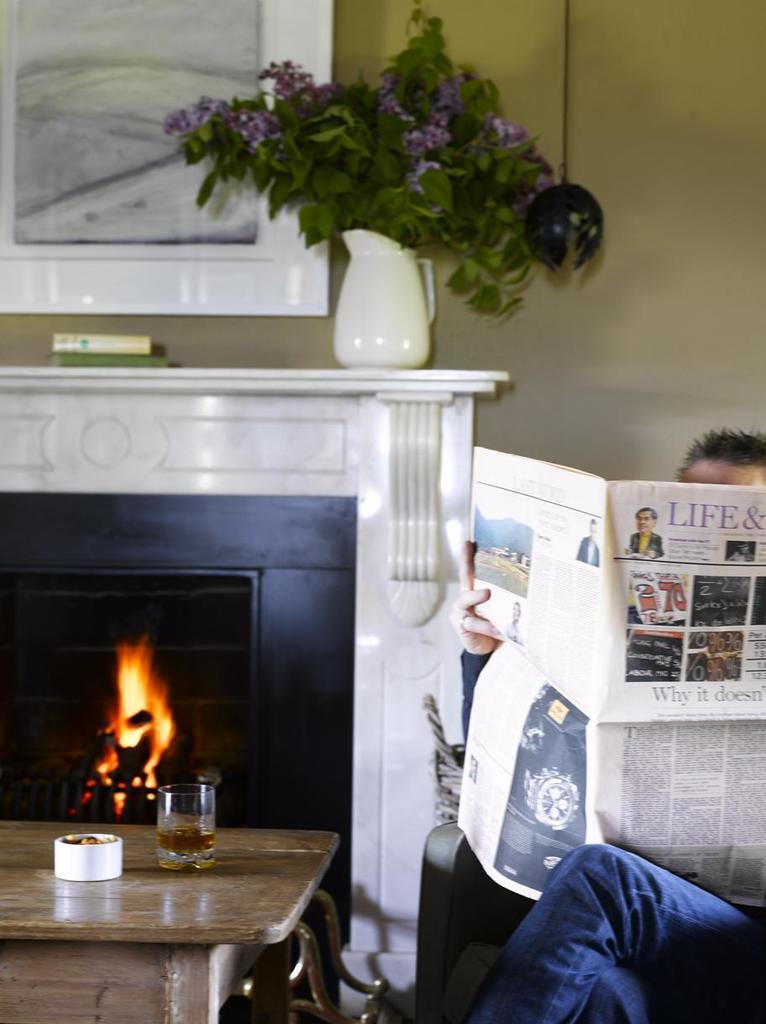In one or two sentences, can you explain what this image depicts? Here we can see a person sitting on the chair and holding a paper. This is a table. On the table there is a glass and an object. Here we can see a wooden oven, flower vase, and a frame. In the background we can see a wall. 